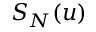<formula> <loc_0><loc_0><loc_500><loc_500>S _ { N } ( u )</formula> 